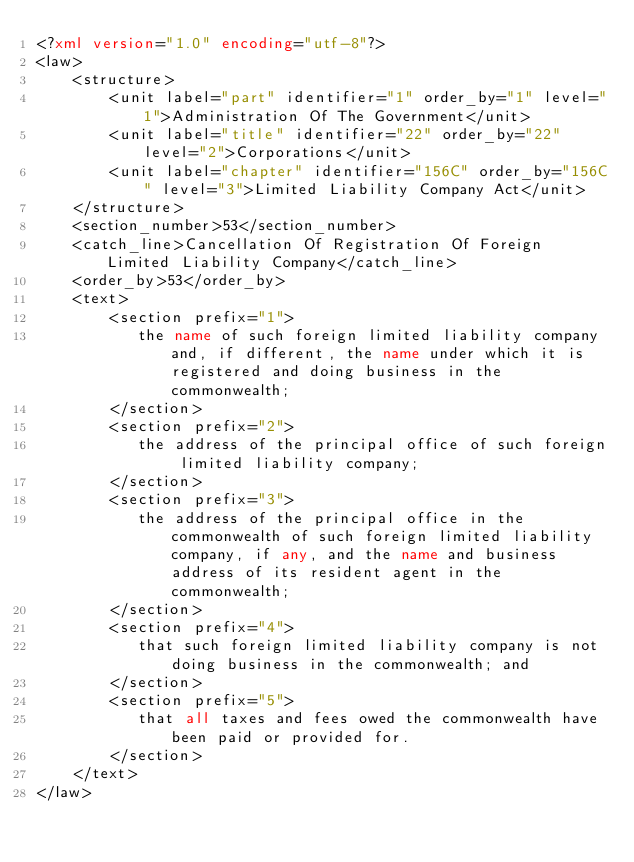Convert code to text. <code><loc_0><loc_0><loc_500><loc_500><_XML_><?xml version="1.0" encoding="utf-8"?>
<law>
    <structure>
        <unit label="part" identifier="1" order_by="1" level="1">Administration Of The Government</unit>
        <unit label="title" identifier="22" order_by="22" level="2">Corporations</unit>
        <unit label="chapter" identifier="156C" order_by="156C" level="3">Limited Liability Company Act</unit>
    </structure>
    <section_number>53</section_number>
    <catch_line>Cancellation Of Registration Of Foreign Limited Liability Company</catch_line>
    <order_by>53</order_by>
    <text>
        <section prefix="1">
    	     the name of such foreign limited liability company and, if different, the name under which it is registered and doing business in the commonwealth;
        </section>
        <section prefix="2">
    	     the address of the principal office of such foreign limited liability company;
        </section>
        <section prefix="3">
    	     the address of the principal office in the commonwealth of such foreign limited liability company, if any, and the name and business address of its resident agent in the commonwealth;
        </section>
        <section prefix="4">
    	     that such foreign limited liability company is not doing business in the commonwealth; and
        </section>
        <section prefix="5">
    	     that all taxes and fees owed the commonwealth have been paid or provided for.
        </section>
    </text>
</law></code> 